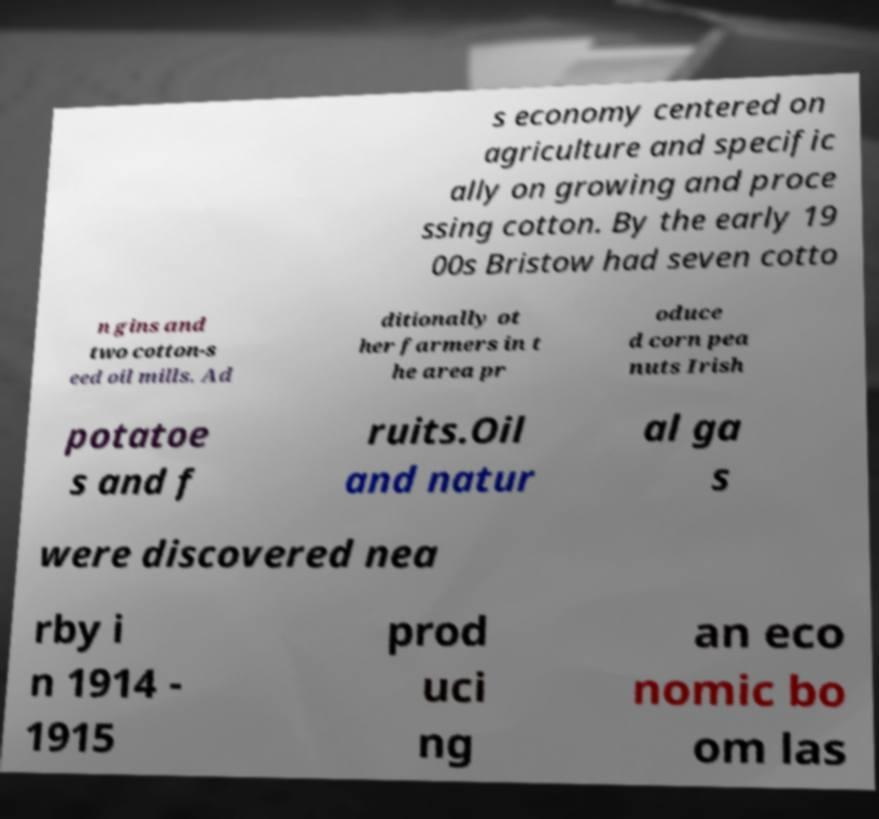I need the written content from this picture converted into text. Can you do that? s economy centered on agriculture and specific ally on growing and proce ssing cotton. By the early 19 00s Bristow had seven cotto n gins and two cotton-s eed oil mills. Ad ditionally ot her farmers in t he area pr oduce d corn pea nuts Irish potatoe s and f ruits.Oil and natur al ga s were discovered nea rby i n 1914 - 1915 prod uci ng an eco nomic bo om las 